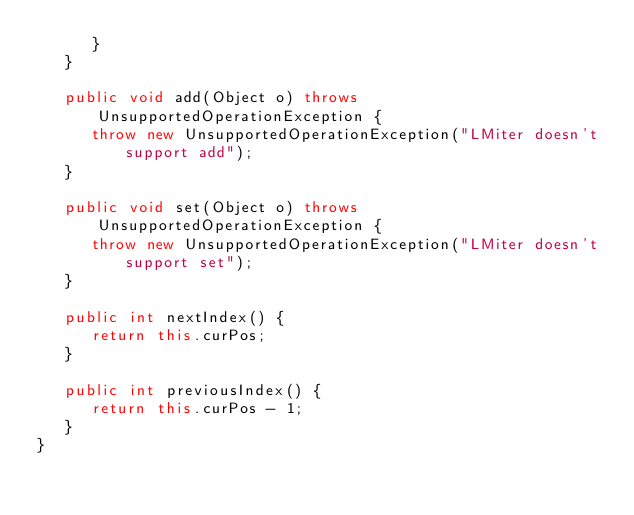Convert code to text. <code><loc_0><loc_0><loc_500><loc_500><_Java_>      }
   }

   public void add(Object o) throws UnsupportedOperationException {
      throw new UnsupportedOperationException("LMiter doesn't support add");
   }

   public void set(Object o) throws UnsupportedOperationException {
      throw new UnsupportedOperationException("LMiter doesn't support set");
   }

   public int nextIndex() {
      return this.curPos;
   }

   public int previousIndex() {
      return this.curPos - 1;
   }
}
</code> 